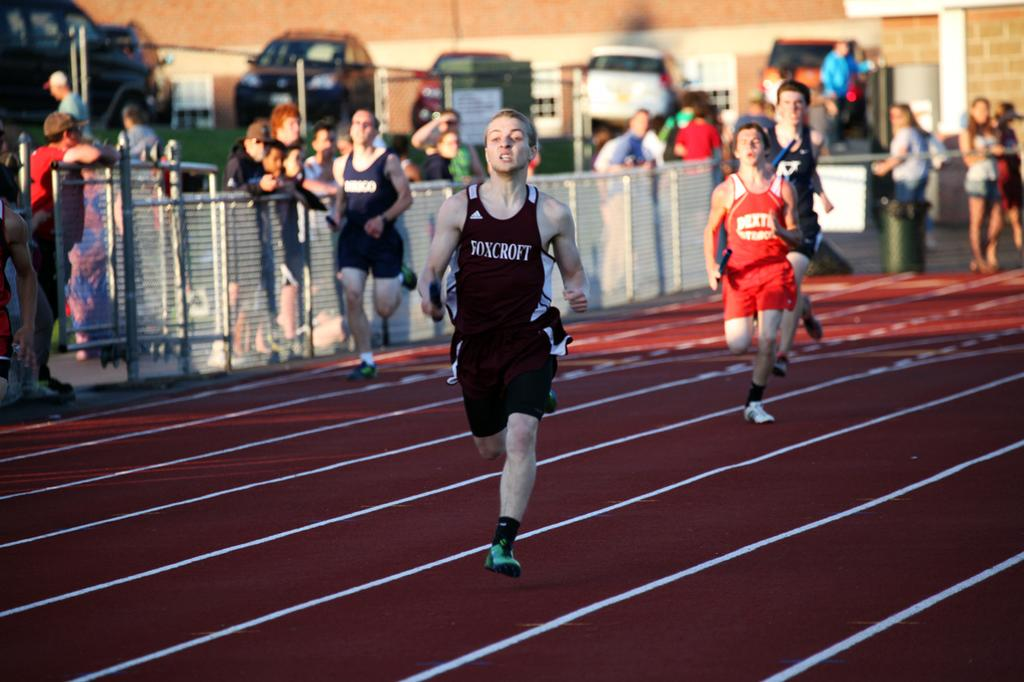Who or what is present in the image? There are people in the image. What are the people doing? The people are running. Can you describe the background of the image? The background of the image is blurred. What else can be seen in the image besides the people? There is fencing visible in the image, and vehicles are present as well. What type of pump is being used by the people in the image? There is no pump present in the image; the people are running. Can you see a kite flying in the image? There is no kite visible in the image. 